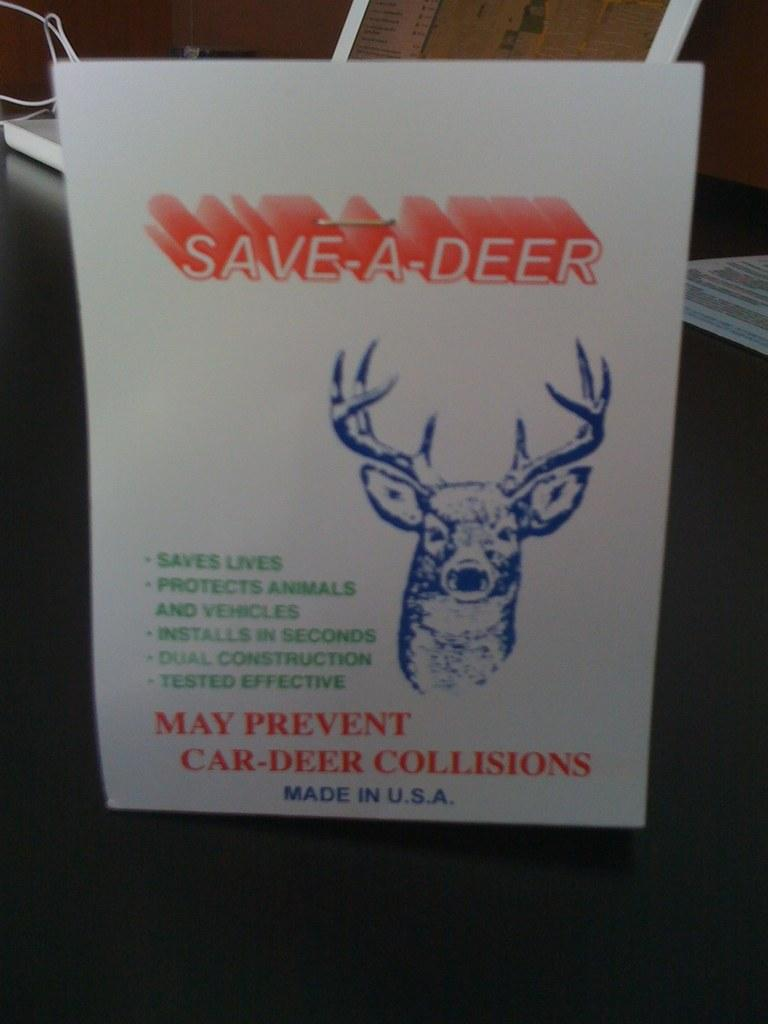What is the main object in the image? There is a paper in the image. Where is the paper located? The paper is placed on a table. How is the paper positioned on the table? The paper is in the center of the image. What type of creature can be seen flying around the paper in the image? There is no creature or flight present in the image; it only features a paper placed on a table. 